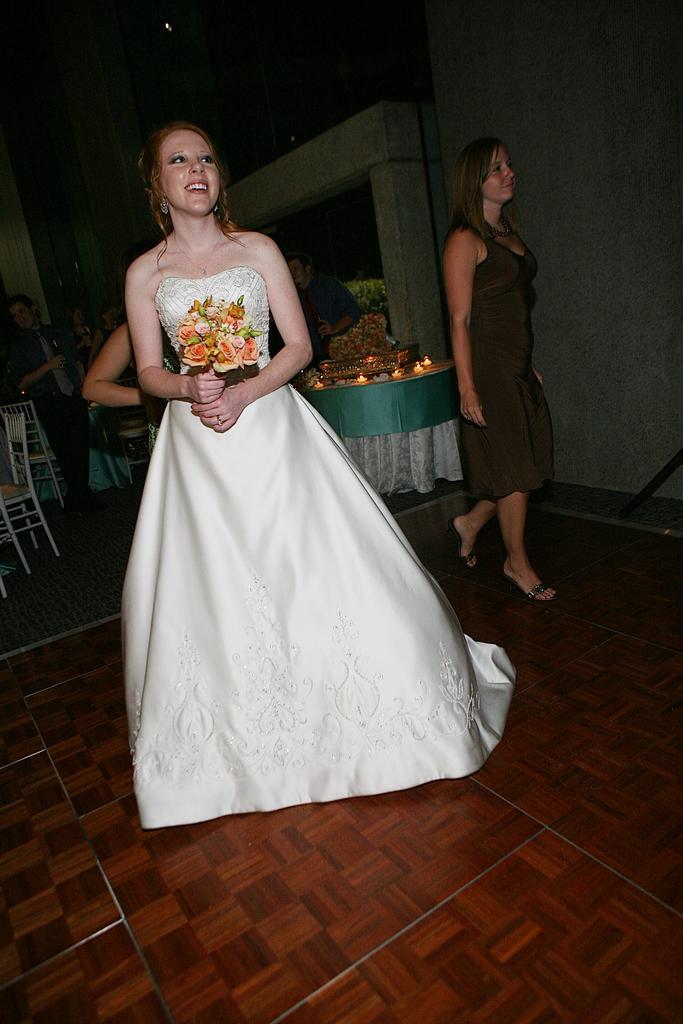In one or two sentences, can you explain what this image depicts? In the picture there is a woman wearing white frock and holding a bunch of flowers in her hand, behind the woman there are some other people and to the left side there are few chairs. 